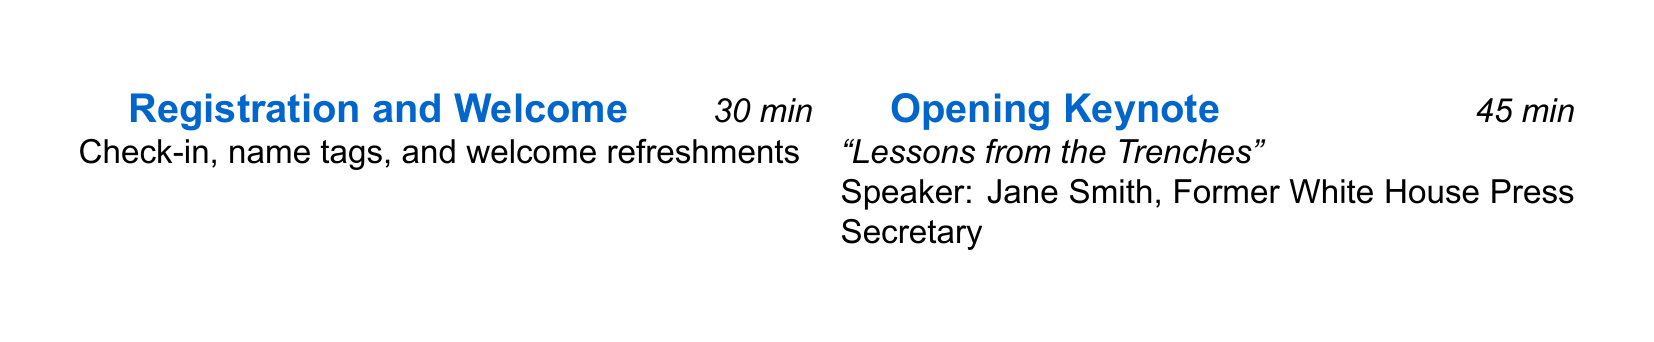What is the date of the event? The event date is stated clearly in the document under event details.
Answer: September 15, 2023 Who is the opening keynote speaker? The speaker name is specified in the agenda under the Opening Keynote section.
Answer: Jane Smith What is the registration fee for the event? The registration fee is mentioned in the event details section.
Answer: $250 (Early Bird: $200) How long is the panel discussion? The duration for the panel discussion is indicated in the agenda items.
Answer: 60 minutes What is the title of the case study presentation? The title of the case study presentation is provided in the relevant agenda item.
Answer: The BP Deepwater Horizon Oil Spill Who facilitates the interactive workshop? The facilitator's name is included in the agenda description for that item.
Answer: Emily Rodriguez What is the total duration of the networking reception? The Total duration is given in the agenda items section.
Answer: 60 minutes Which session focuses on social media? This information can be found within the break-out sessions of the agenda.
Answer: Social Media in Crisis Communications What type of industry professionals is this event designed for? The target audience is described in the event description.
Answer: PR professionals 